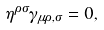Convert formula to latex. <formula><loc_0><loc_0><loc_500><loc_500>\eta ^ { \rho \sigma } \gamma _ { \mu \rho , \sigma } = 0 ,</formula> 